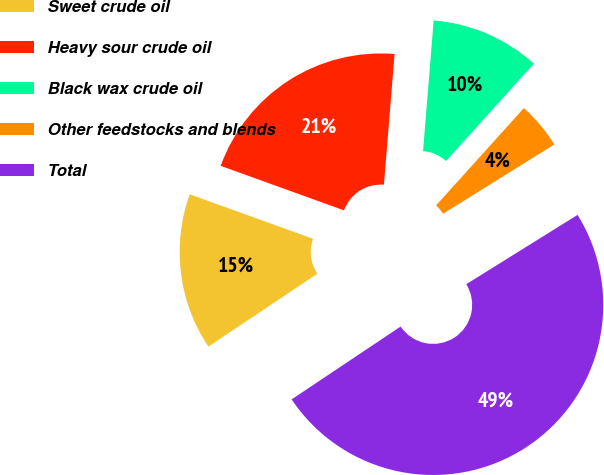Convert chart to OTSL. <chart><loc_0><loc_0><loc_500><loc_500><pie_chart><fcel>Sweet crude oil<fcel>Heavy sour crude oil<fcel>Black wax crude oil<fcel>Other feedstocks and blends<fcel>Total<nl><fcel>14.89%<fcel>20.78%<fcel>10.39%<fcel>4.45%<fcel>49.48%<nl></chart> 